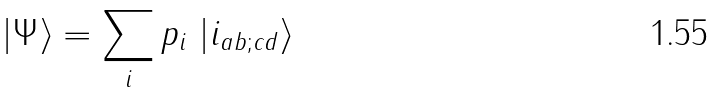Convert formula to latex. <formula><loc_0><loc_0><loc_500><loc_500>\left | \Psi \right \rangle = \sum _ { i } p _ { i } \, \left | i _ { a b ; c d } \right \rangle</formula> 